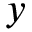<formula> <loc_0><loc_0><loc_500><loc_500>y</formula> 